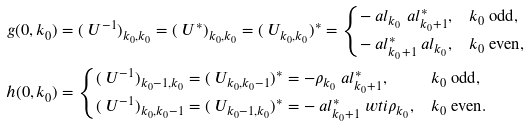<formula> <loc_0><loc_0><loc_500><loc_500>g ( 0 , k _ { 0 } ) & = ( \ U ^ { - 1 } ) _ { k _ { 0 } , k _ { 0 } } = ( \ U ^ { * } ) _ { k _ { 0 } , k _ { 0 } } = ( \ U _ { k _ { 0 } , k _ { 0 } } ) ^ { * } = \begin{cases} - \ a l _ { k _ { 0 } } \ a l _ { k _ { 0 } + 1 } ^ { * } , & k _ { 0 } \text { odd} , \\ - \ a l _ { k _ { 0 } + 1 } ^ { * } \ a l _ { k _ { 0 } } , & k _ { 0 } \text { even} , \end{cases} \\ h ( 0 , k _ { 0 } ) & = \begin{cases} ( \ U ^ { - 1 } ) _ { k _ { 0 } - 1 , k _ { 0 } } = ( \ U _ { k _ { 0 } , k _ { 0 } - 1 } ) ^ { * } = - \rho _ { k _ { 0 } } \ a l _ { k _ { 0 } + 1 } ^ { * } , & k _ { 0 } \text { odd} , \\ ( \ U ^ { - 1 } ) _ { k _ { 0 } , k _ { 0 } - 1 } = ( \ U _ { k _ { 0 } - 1 , k _ { 0 } } ) ^ { * } = - \ a l _ { k _ { 0 } + 1 } ^ { * } \ w t i \rho _ { k _ { 0 } } , & k _ { 0 } \text { even} . \end{cases}</formula> 